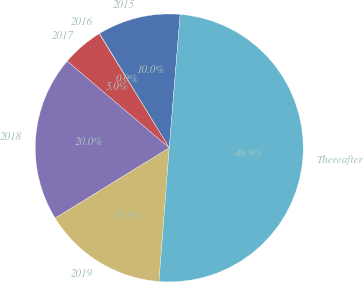Convert chart to OTSL. <chart><loc_0><loc_0><loc_500><loc_500><pie_chart><fcel>2015<fcel>2016<fcel>2017<fcel>2018<fcel>2019<fcel>Thereafter<nl><fcel>10.02%<fcel>0.04%<fcel>5.03%<fcel>19.99%<fcel>15.0%<fcel>49.92%<nl></chart> 